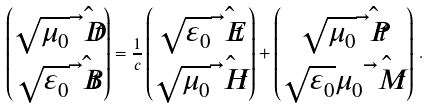<formula> <loc_0><loc_0><loc_500><loc_500>\begin{pmatrix} \sqrt { \mu _ { 0 } } \hat { \vec { t } { D } } \\ \sqrt { \varepsilon _ { 0 } } \hat { \vec { t } { B } } \end{pmatrix} = \frac { 1 } { c } \begin{pmatrix} \sqrt { \varepsilon _ { 0 } } \hat { \vec { t } { E } } \\ \sqrt { \mu _ { 0 } } \hat { \vec { t } { H } } \end{pmatrix} + \begin{pmatrix} \sqrt { \mu _ { 0 } } \hat { \vec { t } { P } } \\ \sqrt { \varepsilon _ { 0 } } \mu _ { 0 } \hat { \vec { t } { M } } \end{pmatrix} \, .</formula> 